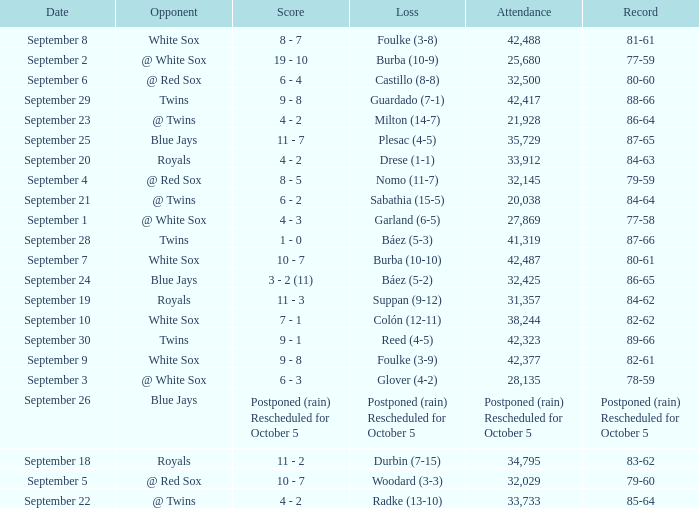What is the score of the game that holds a record of 80-61? 10 - 7. 